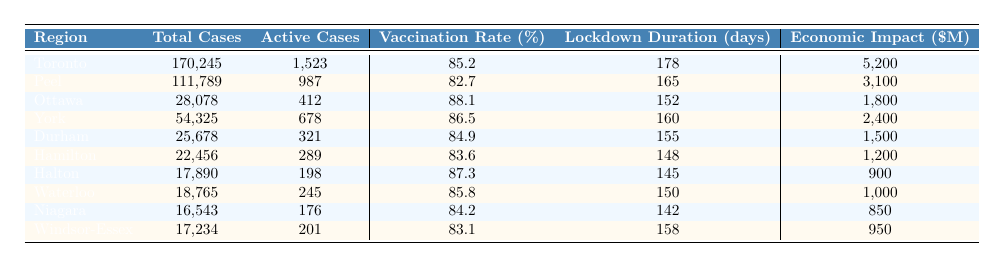What is the total number of COVID-19 cases in Toronto? The table shows that the total cases in Toronto are listed as 170,245.
Answer: 170,245 What is the vaccination rate in Ottawa? The table indicates that the vaccination rate in Ottawa is 88.1%.
Answer: 88.1% Which region has the highest economic impact due to COVID-19? By comparing the economic impacts in the table, Toronto has the highest economic impact at 5,200 million dollars.
Answer: Toronto What is the average vaccination rate across all listed regions? The vaccination rates are 85.2, 82.7, 88.1, 86.5, 84.9, 83.6, 87.3, 85.8, 84.2, and 83.1. The sum of these rates is  866.4, and there are 10 regions, so the average is 866.4/10 = 86.64%.
Answer: 86.64% How many more active cases are there in Peel compared to Halton? The active cases in Peel are 987 and in Halton are 198. The difference is 987 - 198 = 789.
Answer: 789 Is the lockdown duration in Durham longer than in Hamilton? The lockdown duration for Durham is 155 days, while Hamilton is 148 days. Since 155 > 148, the answer is yes.
Answer: Yes What is the total economic impact of the regions listed in the table? The economic impacts are 5200, 3100, 1800, 2400, 1500, 1200, 900, 1000, 850, and 950. Adding these up gives a total of 17,050 million dollars.
Answer: 17,050 Which region has the lowest vaccination rate? Comparing the vaccination rates, Windsor-Essex has the lowest at 83.1%.
Answer: Windsor-Essex How many days of lockdown did the region with the most active cases experience? Toronto has the most active cases at 1,523 and experienced a lockdown for 178 days.
Answer: 178 Among the regions with a vaccination rate over 85%, which region had the least economic impact? The regions with a vaccination rate over 85% are Toronto (5200 million), Ottawa (1800 million), York (2400 million), Halton (900 million), and Waterloo (1000 million). Halton has the least economic impact at 900 million.
Answer: Halton 